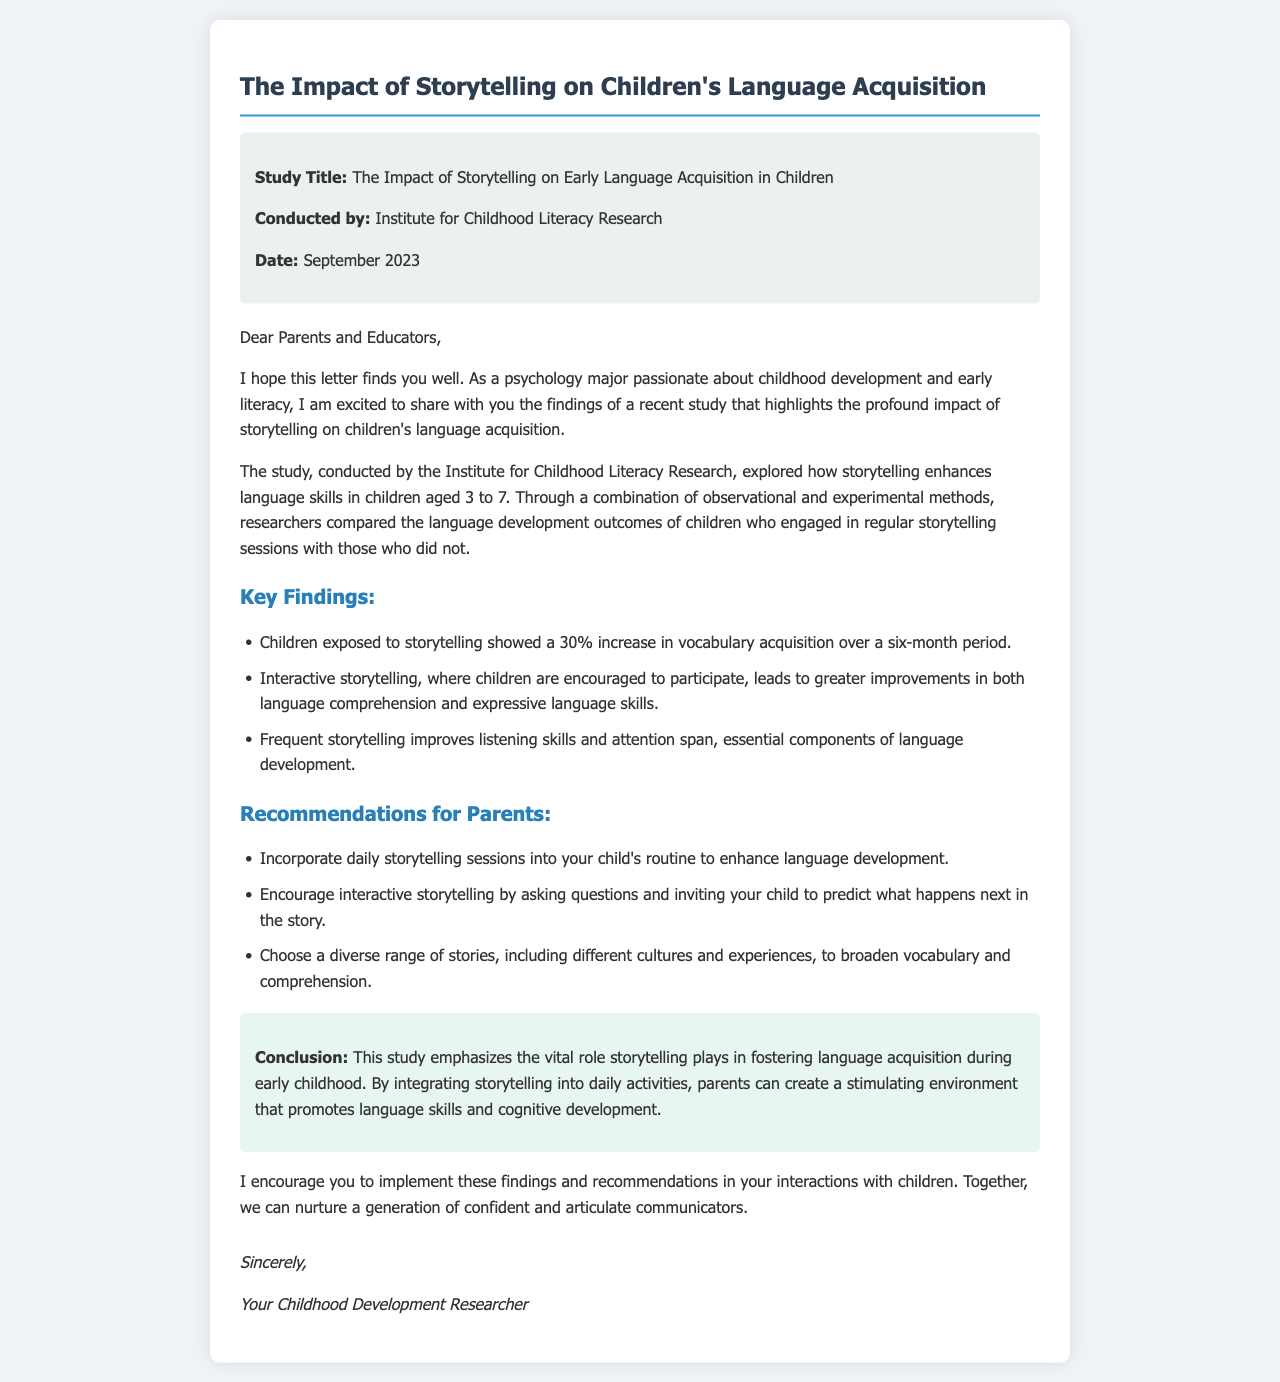What is the study title? The study title is explicitly stated at the beginning of the document.
Answer: The Impact of Storytelling on Early Language Acquisition in Children Who conducted the study? The name of the organization that conducted the study is provided in the document.
Answer: Institute for Childhood Literacy Research When was the study conducted? The date of the study is mentioned in the introductory section of the letter.
Answer: September 2023 What percentage increase in vocabulary acquisition was observed? The document states the specific percentage increase regarding vocabulary acquisition clearly.
Answer: 30% What age group was the study focused on? The letter specifies the age range of children that the study targeted.
Answer: 3 to 7 What is one recommendation for parents? One recommendation for parents is explicitly listed in the recommendations section of the letter.
Answer: Incorporate daily storytelling sessions What did interactive storytelling improve? The outcomes of interactive storytelling are outlined, specifying skills it enhances.
Answer: Language comprehension and expressive language skills What role does storytelling play in child development according to the study? The conclusion summarizing the study's implications describes the role of storytelling succinctly.
Answer: Vital role What method was used to conduct the study? The letter mentions the combination of methods used in the research.
Answer: Observational and experimental methods What kind of environment does storytelling create for children? The conclusion states the type of environment storytelling fosters in children's development.
Answer: Stimulating environment 